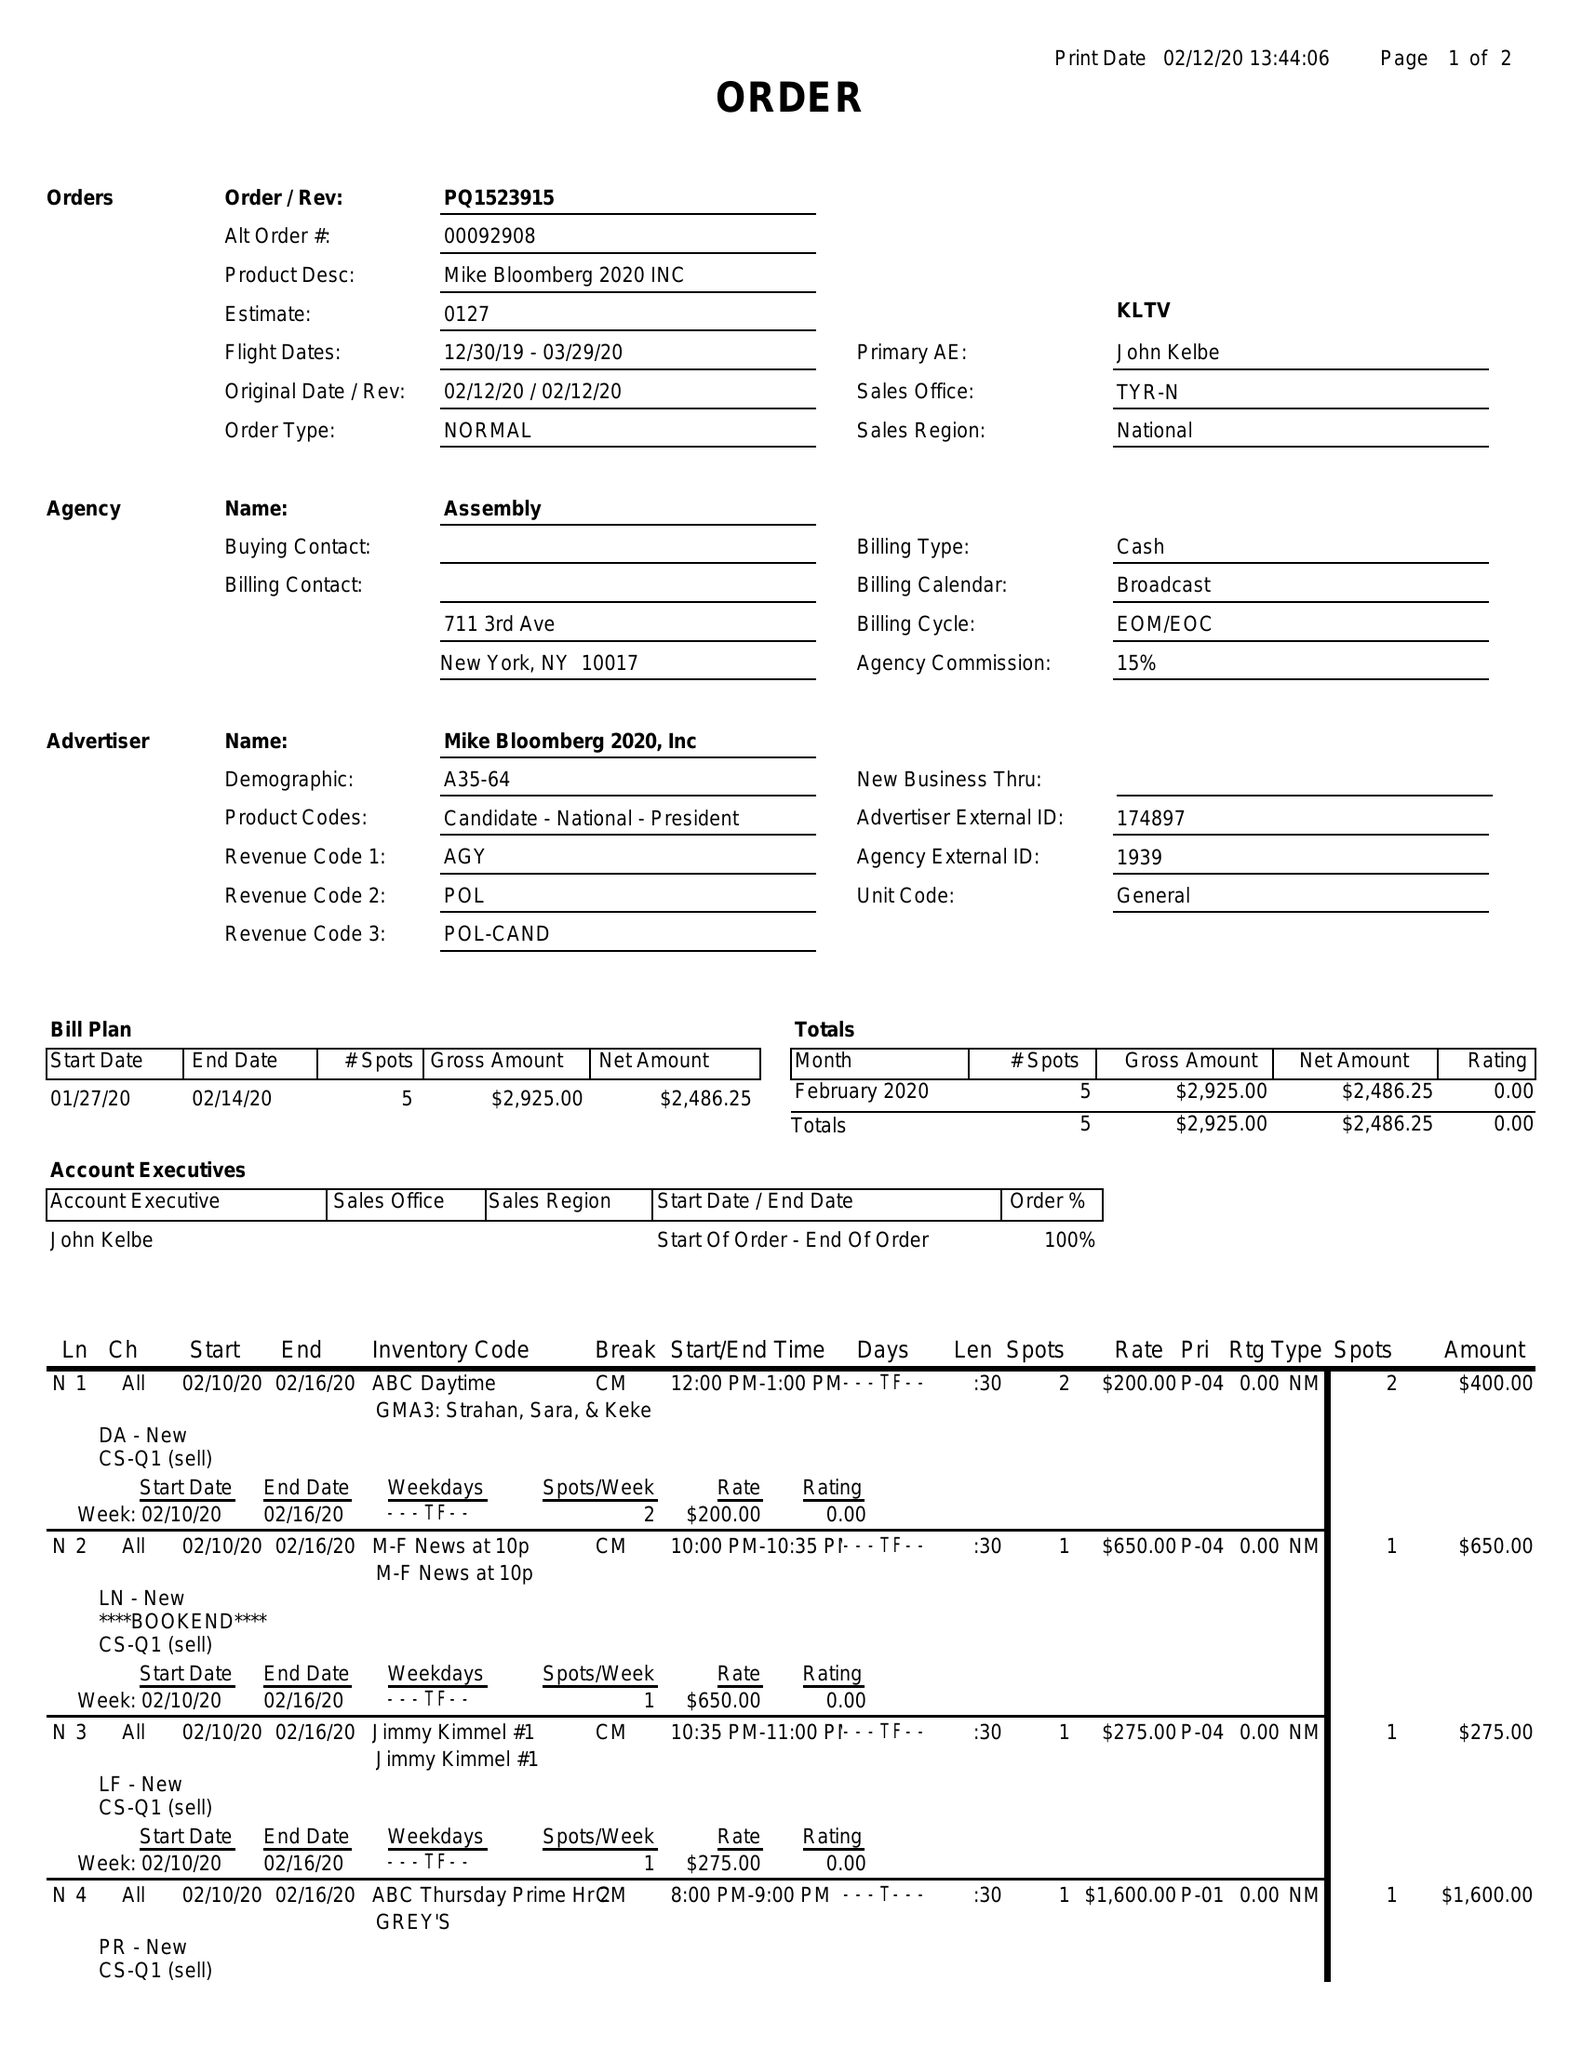What is the value for the flight_to?
Answer the question using a single word or phrase. 03/29/20 